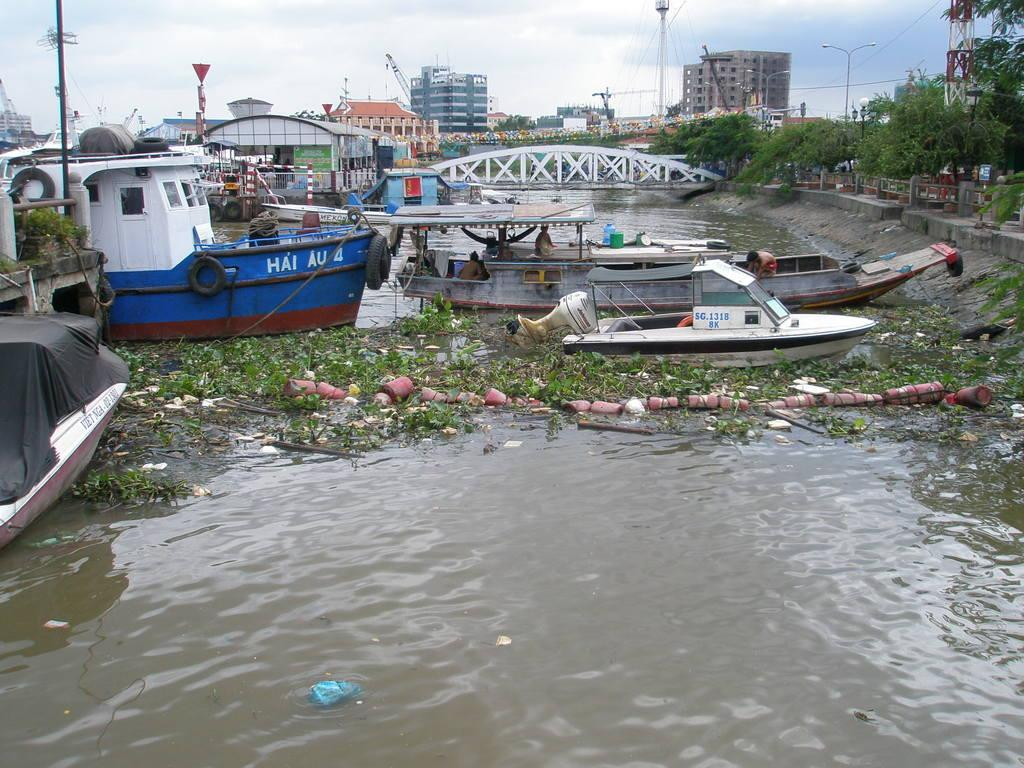What is the main subject of the image? The main subject of the image is ships in a lake. What else can be seen in the image besides the ships? There are buildings and trees visible in the image. Where is the cactus located in the image? There is no cactus present in the image. What type of cup can be seen in the hands of the people on the ships? There are no people or cups visible in the image. 